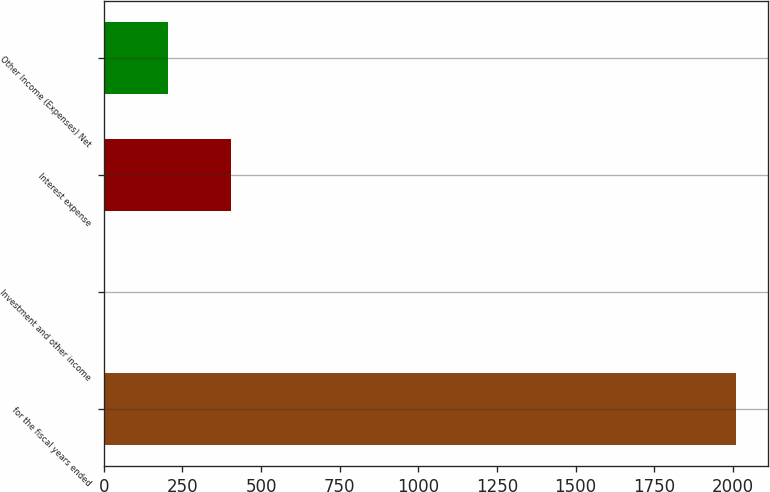<chart> <loc_0><loc_0><loc_500><loc_500><bar_chart><fcel>for the fiscal years ended<fcel>Investment and other income<fcel>Interest expense<fcel>Other Income (Expenses) Net<nl><fcel>2011<fcel>1.8<fcel>403.64<fcel>202.72<nl></chart> 